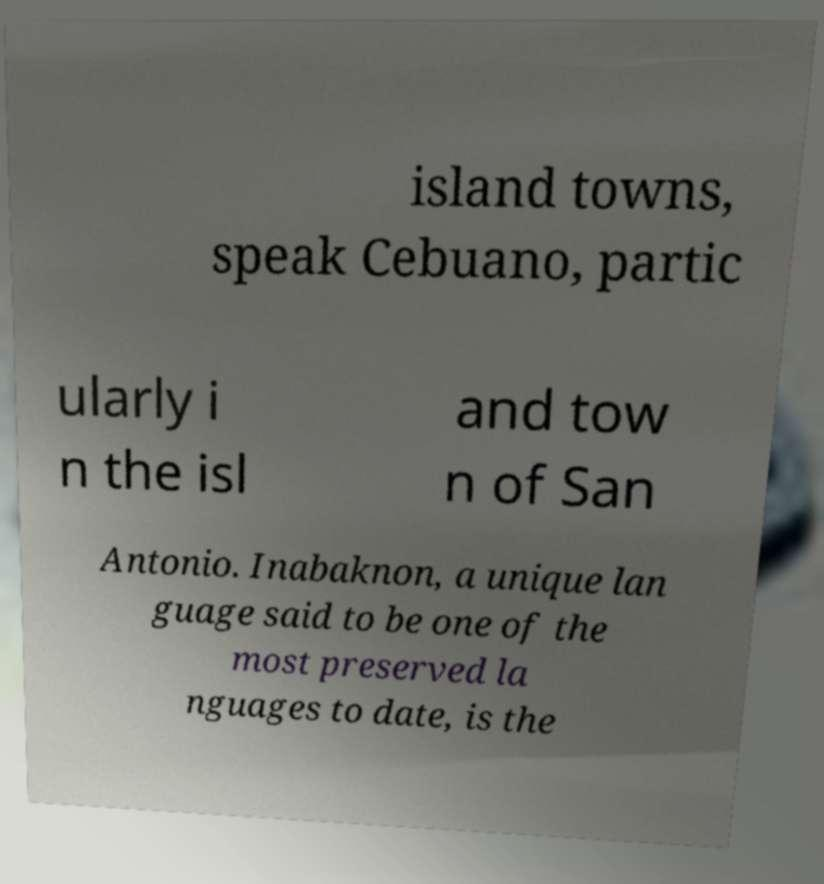Please read and relay the text visible in this image. What does it say? island towns, speak Cebuano, partic ularly i n the isl and tow n of San Antonio. Inabaknon, a unique lan guage said to be one of the most preserved la nguages to date, is the 